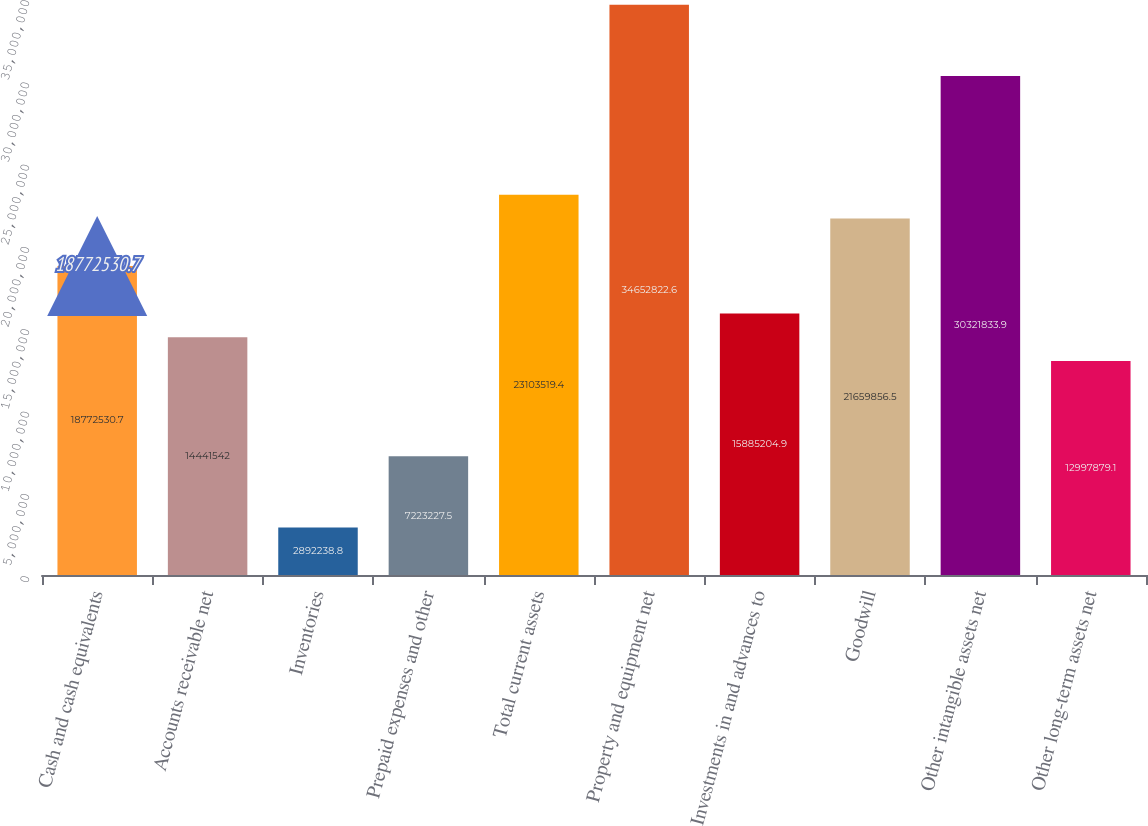<chart> <loc_0><loc_0><loc_500><loc_500><bar_chart><fcel>Cash and cash equivalents<fcel>Accounts receivable net<fcel>Inventories<fcel>Prepaid expenses and other<fcel>Total current assets<fcel>Property and equipment net<fcel>Investments in and advances to<fcel>Goodwill<fcel>Other intangible assets net<fcel>Other long-term assets net<nl><fcel>1.87725e+07<fcel>1.44415e+07<fcel>2.89224e+06<fcel>7.22323e+06<fcel>2.31035e+07<fcel>3.46528e+07<fcel>1.58852e+07<fcel>2.16599e+07<fcel>3.03218e+07<fcel>1.29979e+07<nl></chart> 